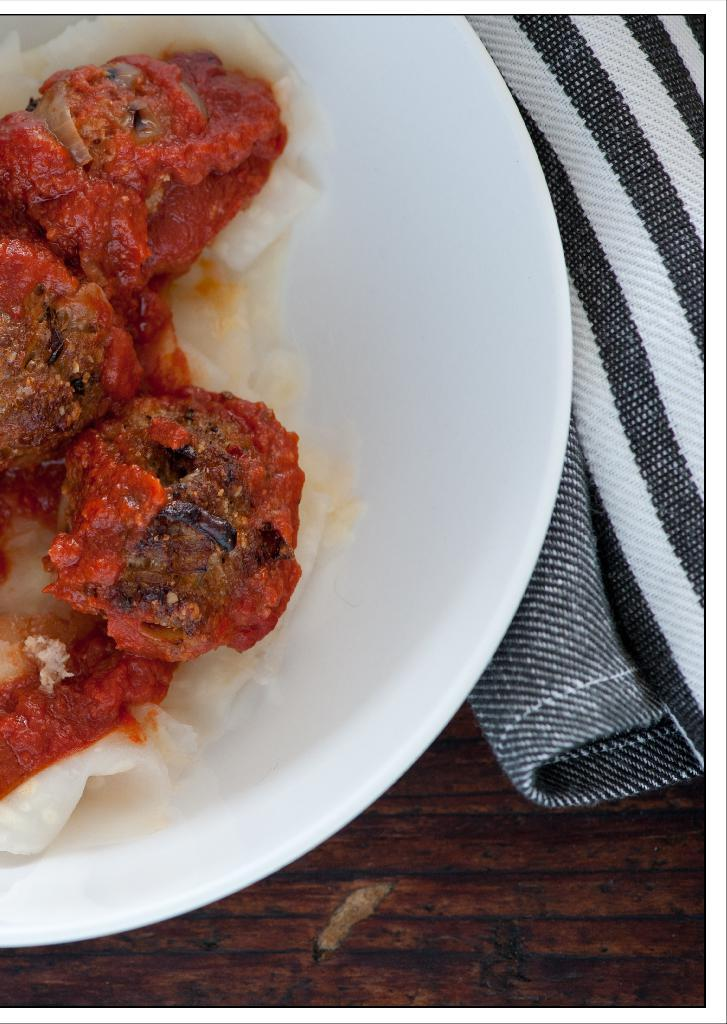What piece of furniture is visible in the image? There is a table in the image. What is on the table in the image? There is a plate full of food on the table. What item is present near the plate for wiping or cleaning? There is a napkin present near the plate. What type of cap is being worn by the flowers in the image? There are no caps or flowers present in the image; it only features a table, a plate full of food, and a napkin. 